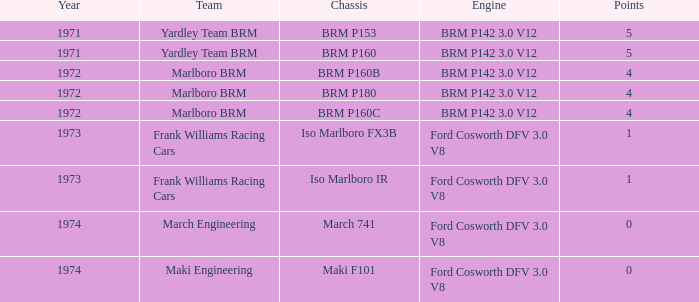Which chassis has marlboro brm as the team? BRM P160B, BRM P180, BRM P160C. Help me parse the entirety of this table. {'header': ['Year', 'Team', 'Chassis', 'Engine', 'Points'], 'rows': [['1971', 'Yardley Team BRM', 'BRM P153', 'BRM P142 3.0 V12', '5'], ['1971', 'Yardley Team BRM', 'BRM P160', 'BRM P142 3.0 V12', '5'], ['1972', 'Marlboro BRM', 'BRM P160B', 'BRM P142 3.0 V12', '4'], ['1972', 'Marlboro BRM', 'BRM P180', 'BRM P142 3.0 V12', '4'], ['1972', 'Marlboro BRM', 'BRM P160C', 'BRM P142 3.0 V12', '4'], ['1973', 'Frank Williams Racing Cars', 'Iso Marlboro FX3B', 'Ford Cosworth DFV 3.0 V8', '1'], ['1973', 'Frank Williams Racing Cars', 'Iso Marlboro IR', 'Ford Cosworth DFV 3.0 V8', '1'], ['1974', 'March Engineering', 'March 741', 'Ford Cosworth DFV 3.0 V8', '0'], ['1974', 'Maki Engineering', 'Maki F101', 'Ford Cosworth DFV 3.0 V8', '0']]} 